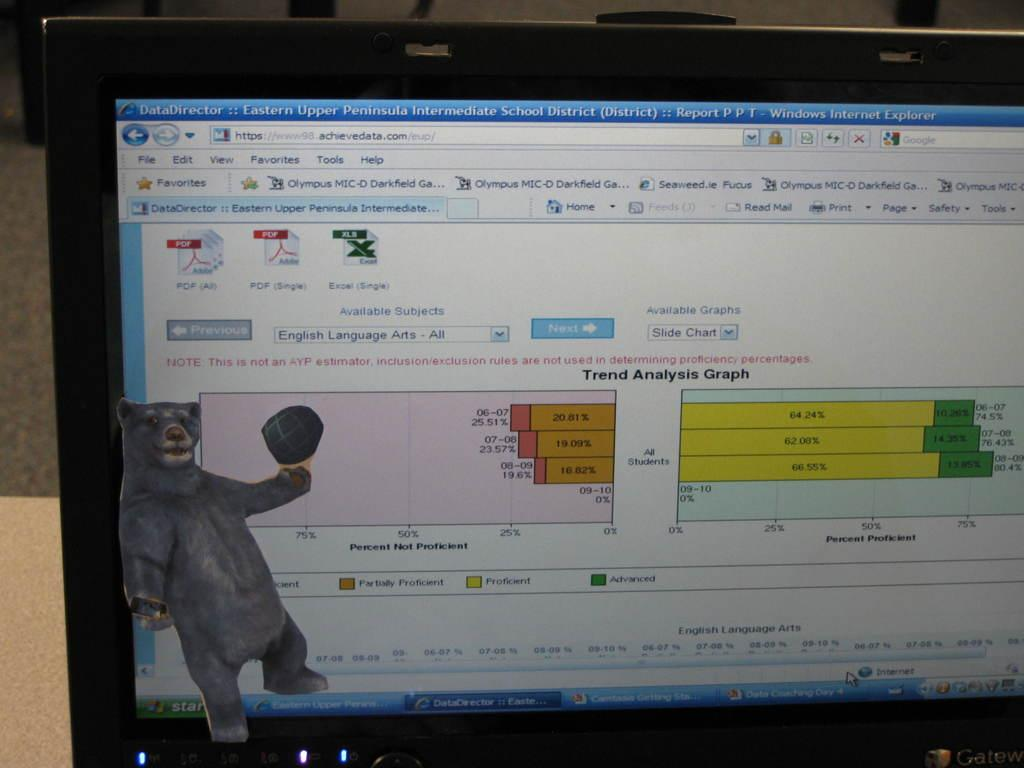Provide a one-sentence caption for the provided image. Monitor showing an internet explorer page on "achievedata.com". 